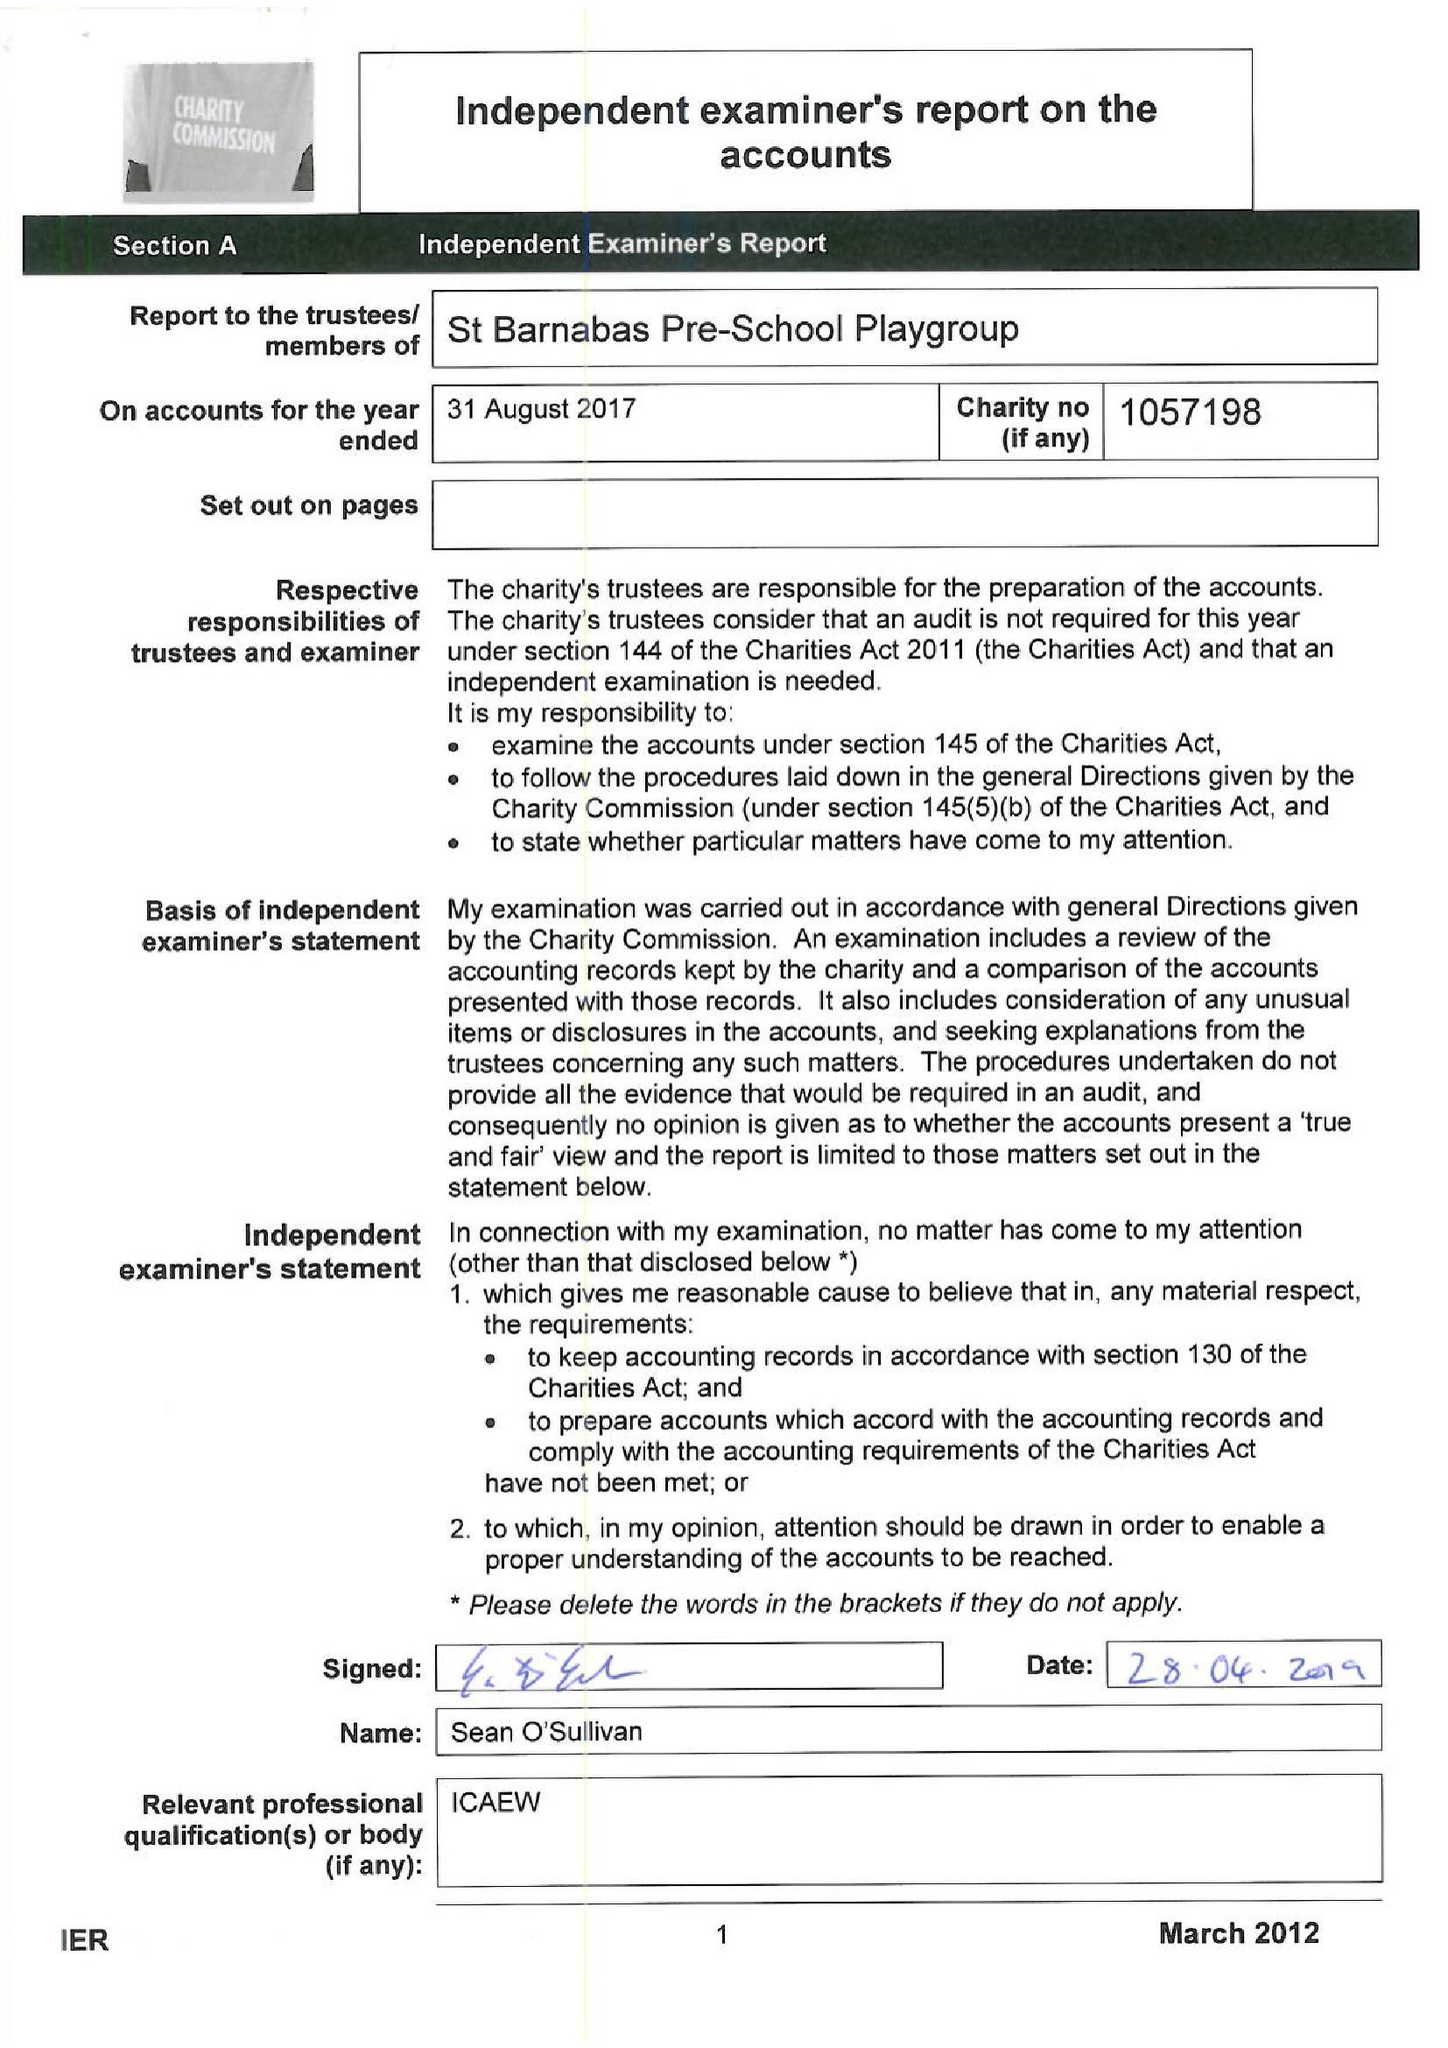What is the value for the spending_annually_in_british_pounds?
Answer the question using a single word or phrase. 60085.00 